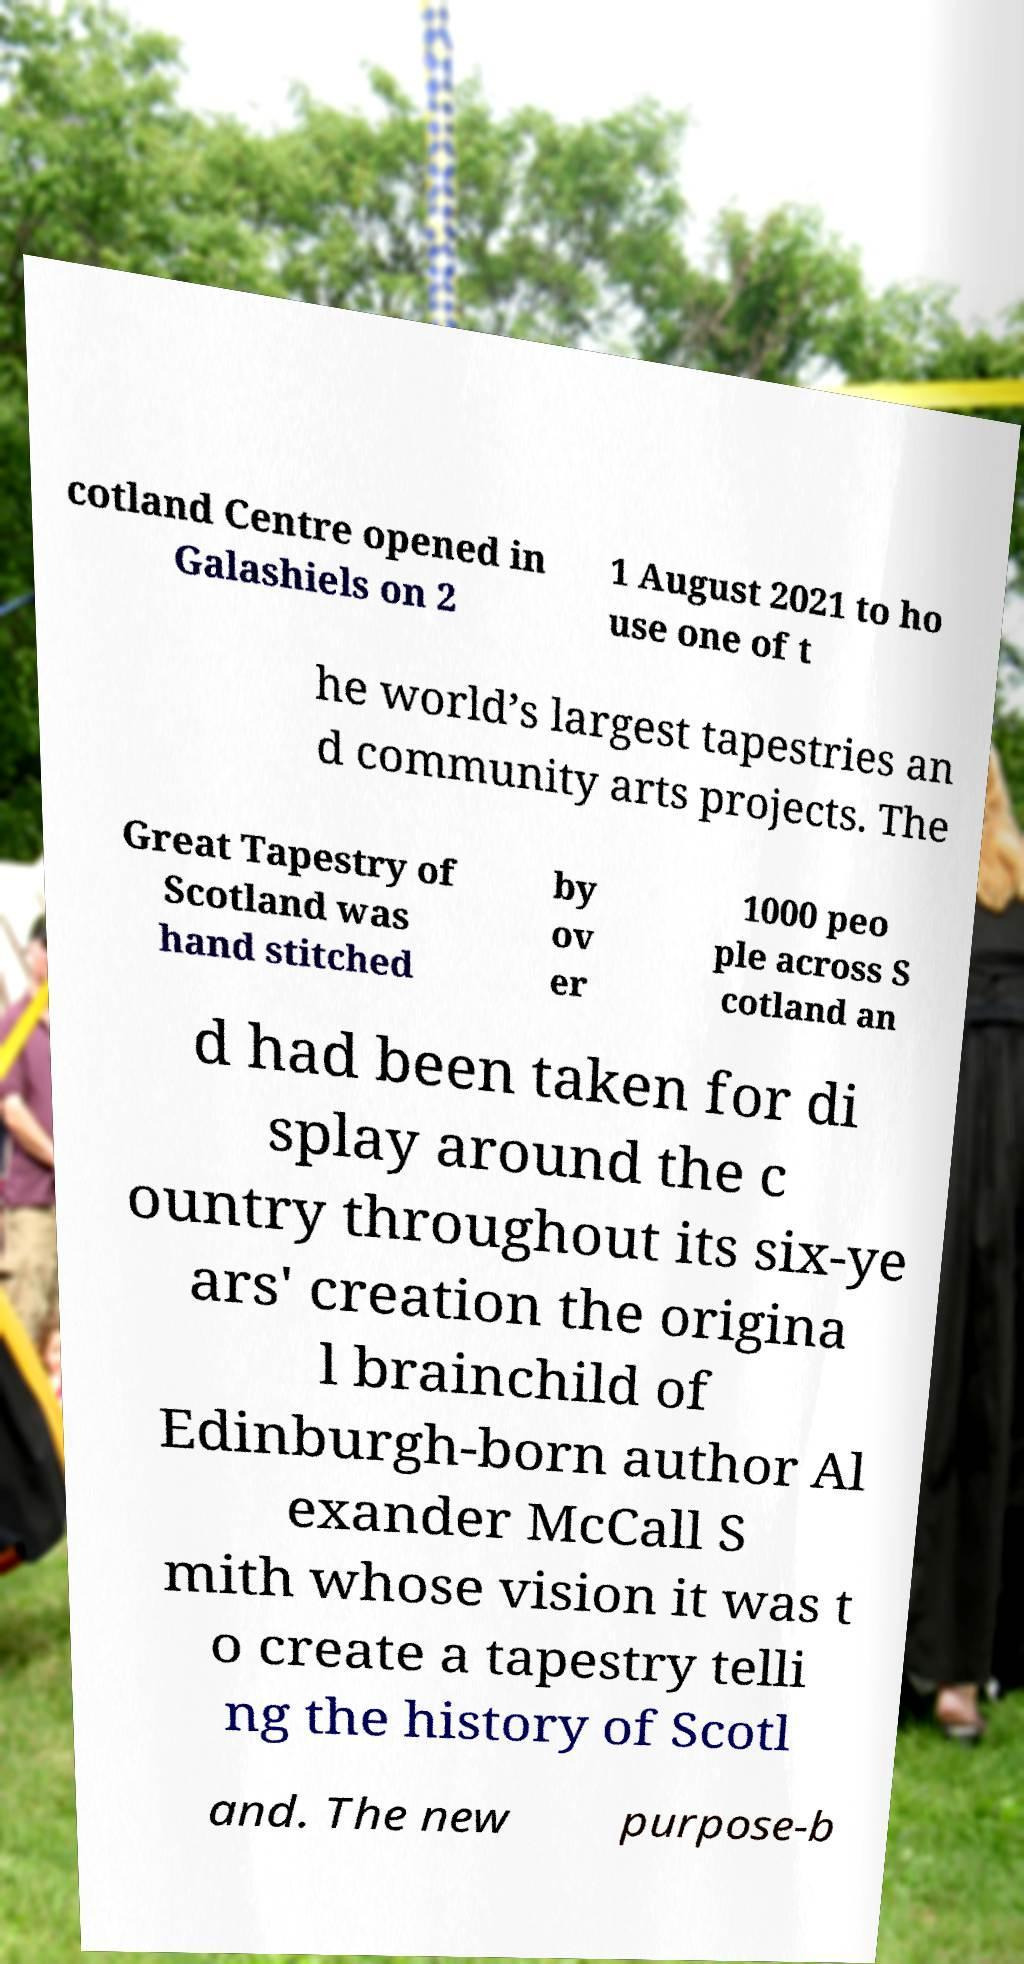Please read and relay the text visible in this image. What does it say? cotland Centre opened in Galashiels on 2 1 August 2021 to ho use one of t he world’s largest tapestries an d community arts projects. The Great Tapestry of Scotland was hand stitched by ov er 1000 peo ple across S cotland an d had been taken for di splay around the c ountry throughout its six-ye ars' creation the origina l brainchild of Edinburgh-born author Al exander McCall S mith whose vision it was t o create a tapestry telli ng the history of Scotl and. The new purpose-b 